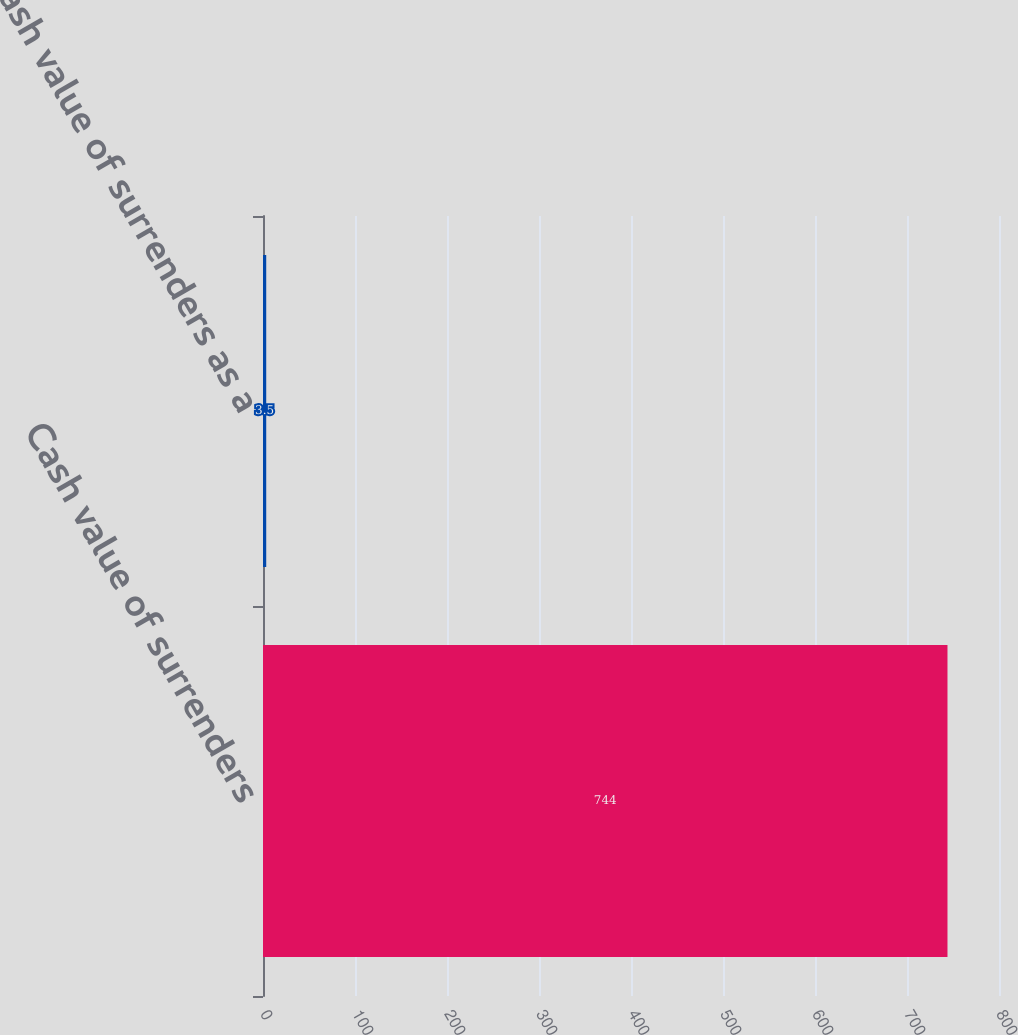Convert chart. <chart><loc_0><loc_0><loc_500><loc_500><bar_chart><fcel>Cash value of surrenders<fcel>Cash value of surrenders as a<nl><fcel>744<fcel>3.5<nl></chart> 